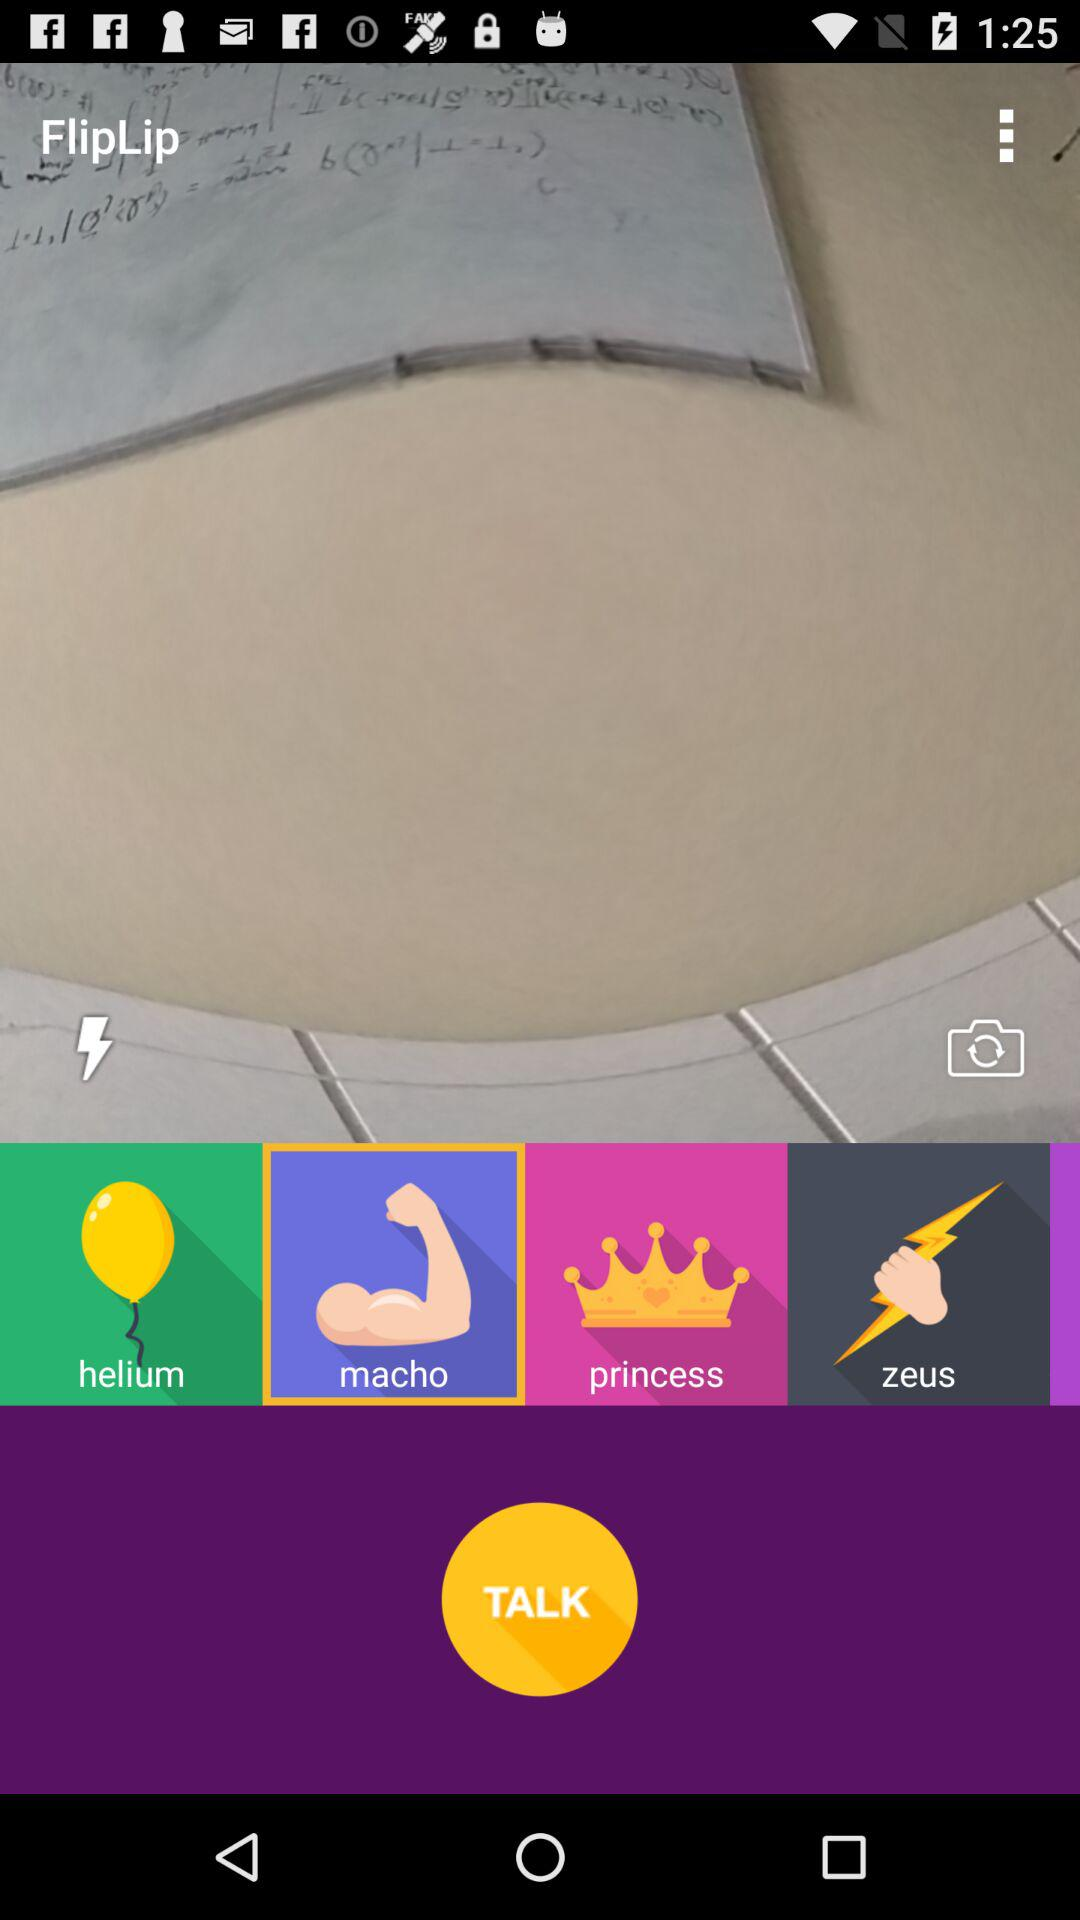Which option is selected? The selected option is "macho". 